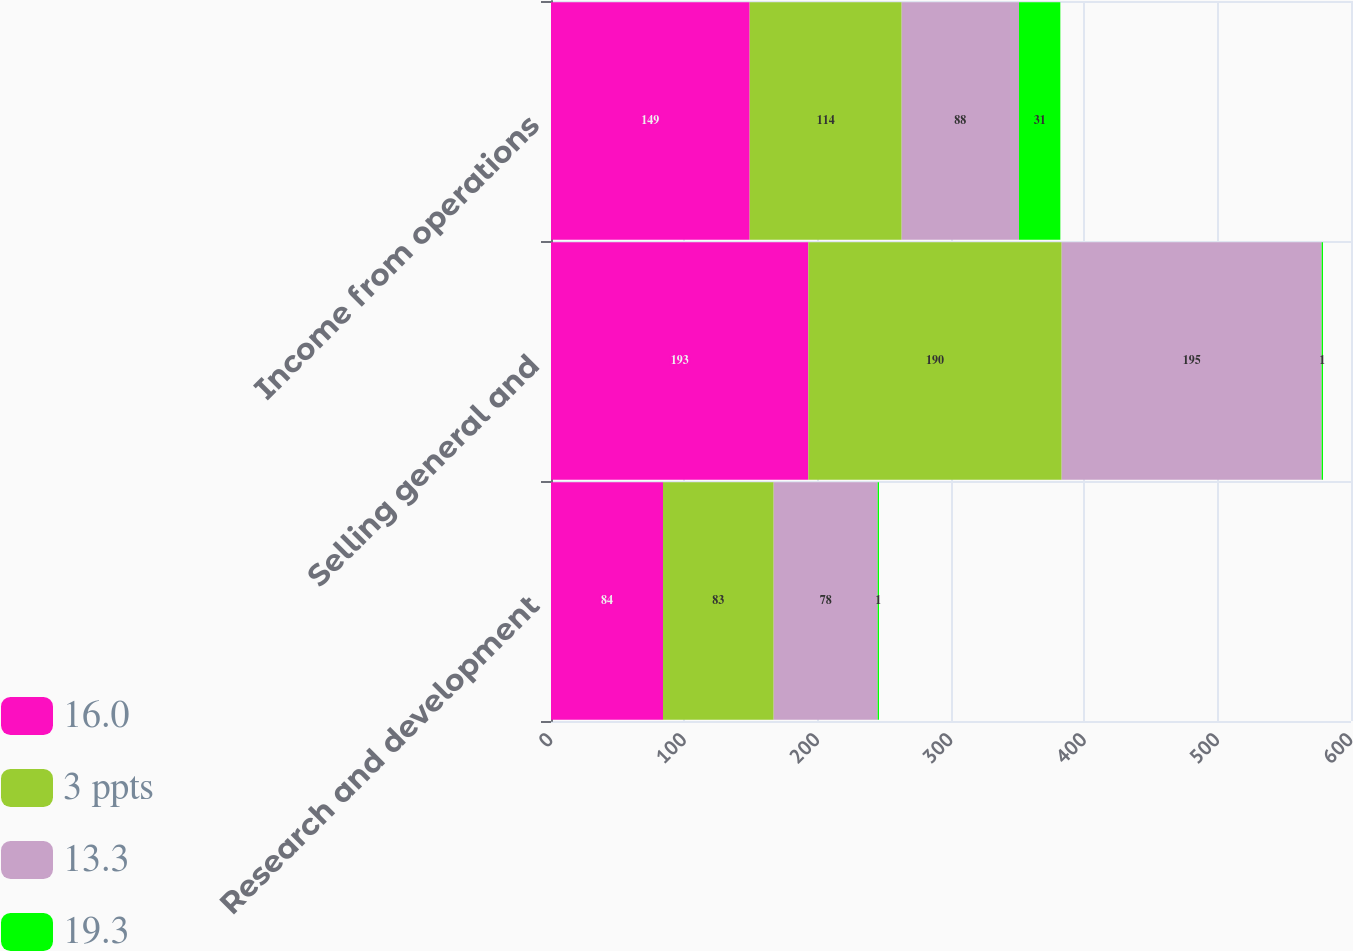Convert chart. <chart><loc_0><loc_0><loc_500><loc_500><stacked_bar_chart><ecel><fcel>Research and development<fcel>Selling general and<fcel>Income from operations<nl><fcel>16.0<fcel>84<fcel>193<fcel>149<nl><fcel>3 ppts<fcel>83<fcel>190<fcel>114<nl><fcel>13.3<fcel>78<fcel>195<fcel>88<nl><fcel>19.3<fcel>1<fcel>1<fcel>31<nl></chart> 